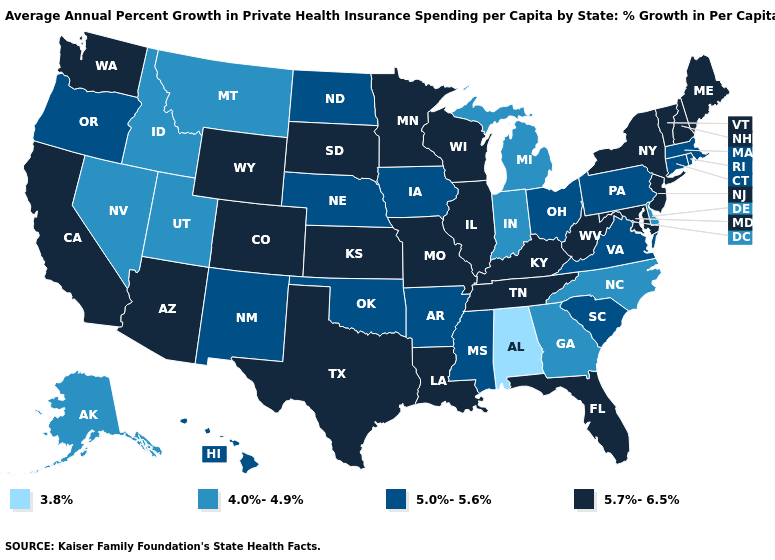What is the value of Nevada?
Keep it brief. 4.0%-4.9%. Name the states that have a value in the range 5.7%-6.5%?
Be succinct. Arizona, California, Colorado, Florida, Illinois, Kansas, Kentucky, Louisiana, Maine, Maryland, Minnesota, Missouri, New Hampshire, New Jersey, New York, South Dakota, Tennessee, Texas, Vermont, Washington, West Virginia, Wisconsin, Wyoming. What is the value of Missouri?
Keep it brief. 5.7%-6.5%. What is the value of Virginia?
Quick response, please. 5.0%-5.6%. Name the states that have a value in the range 3.8%?
Write a very short answer. Alabama. Does Wisconsin have the highest value in the USA?
Be succinct. Yes. Does North Dakota have a higher value than Kansas?
Short answer required. No. Among the states that border Tennessee , which have the lowest value?
Quick response, please. Alabama. Among the states that border Oklahoma , does Texas have the lowest value?
Be succinct. No. Which states hav the highest value in the MidWest?
Keep it brief. Illinois, Kansas, Minnesota, Missouri, South Dakota, Wisconsin. Among the states that border Oregon , which have the lowest value?
Answer briefly. Idaho, Nevada. What is the value of Arkansas?
Short answer required. 5.0%-5.6%. Does Illinois have a lower value than West Virginia?
Short answer required. No. What is the value of Arizona?
Quick response, please. 5.7%-6.5%. Among the states that border Missouri , does Iowa have the lowest value?
Keep it brief. Yes. 